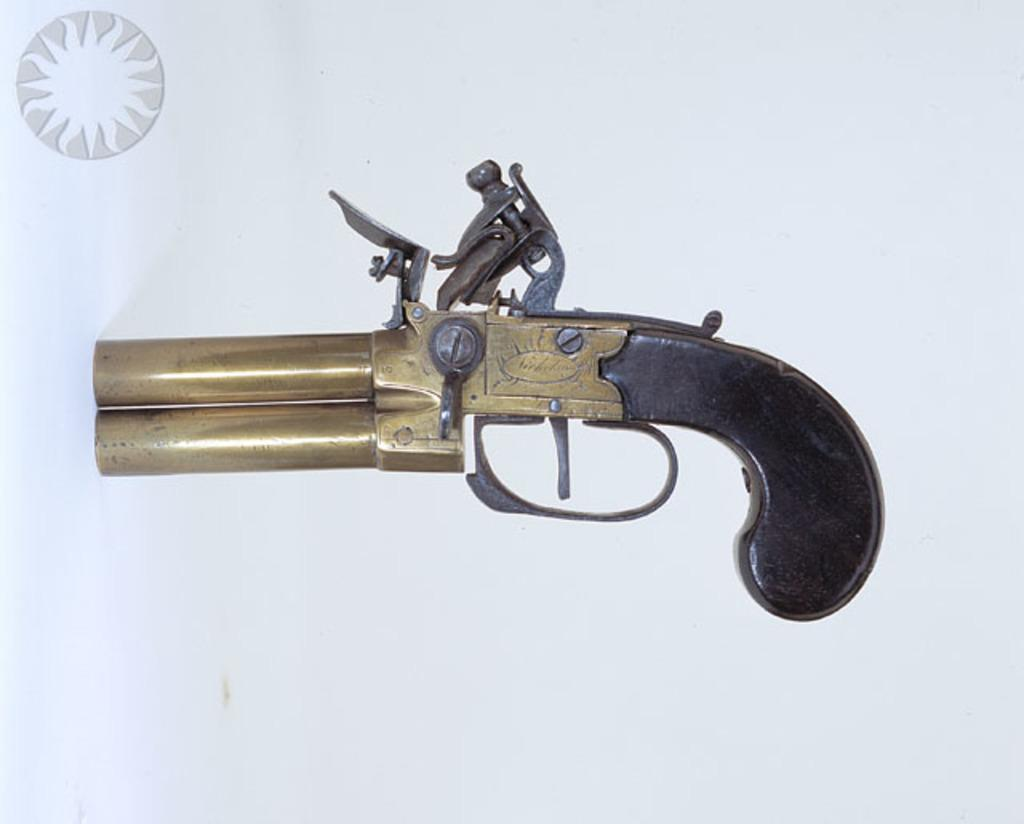What is the main object in the picture? There is a gun in the picture. Is there any text or symbol in the picture? Yes, there is a logo in the top left corner of the picture. What color is the background of the picture? The background of the picture is white. What type of birds can be seen eating breakfast in the picture? There are no birds or breakfast present in the picture; it features a gun and a logo on a white background. 